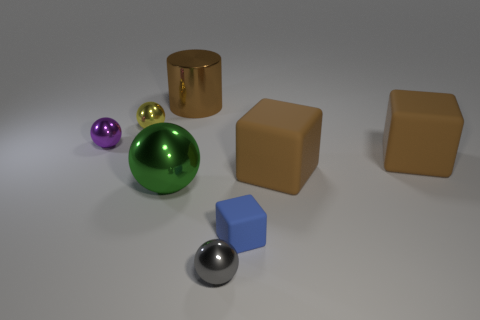Subtract 1 spheres. How many spheres are left? 3 Add 1 green matte cubes. How many objects exist? 9 Subtract all cylinders. How many objects are left? 7 Add 3 brown matte cubes. How many brown matte cubes are left? 5 Add 6 large yellow cylinders. How many large yellow cylinders exist? 6 Subtract 1 yellow balls. How many objects are left? 7 Subtract all large green rubber cylinders. Subtract all small purple balls. How many objects are left? 7 